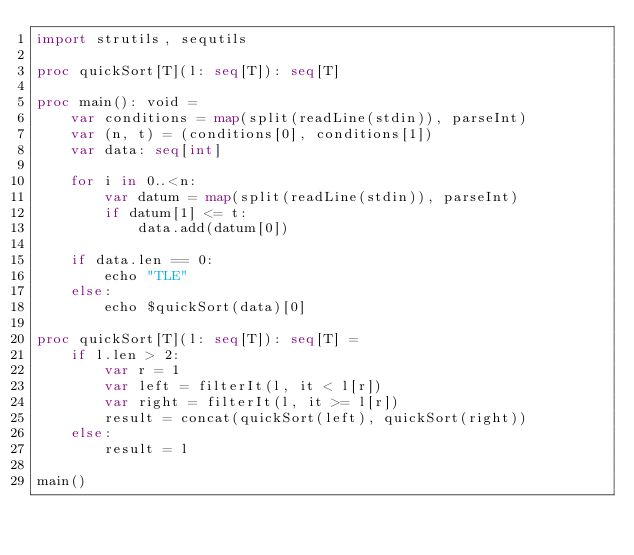<code> <loc_0><loc_0><loc_500><loc_500><_Nim_>import strutils, sequtils

proc quickSort[T](l: seq[T]): seq[T]

proc main(): void = 
    var conditions = map(split(readLine(stdin)), parseInt)
    var (n, t) = (conditions[0], conditions[1])
    var data: seq[int]

    for i in 0..<n:
        var datum = map(split(readLine(stdin)), parseInt)
        if datum[1] <= t:
            data.add(datum[0])

    if data.len == 0:
        echo "TLE"
    else:
        echo $quickSort(data)[0]
    
proc quickSort[T](l: seq[T]): seq[T] =
    if l.len > 2:
        var r = 1
        var left = filterIt(l, it < l[r])
        var right = filterIt(l, it >= l[r])
        result = concat(quickSort(left), quickSort(right))
    else:
        result = l

main()</code> 